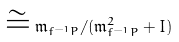Convert formula to latex. <formula><loc_0><loc_0><loc_500><loc_500>\cong { \mathfrak { m } } _ { f ^ { - 1 } P } / ( { \mathfrak { m } } _ { f ^ { - 1 } P } ^ { 2 } + I )</formula> 